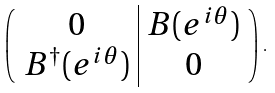Convert formula to latex. <formula><loc_0><loc_0><loc_500><loc_500>\left ( \begin{array} { c | c } 0 & B ( e ^ { i \theta } ) \\ B ^ { \dagger } ( e ^ { i \theta } ) & 0 \end{array} \right ) \, .</formula> 